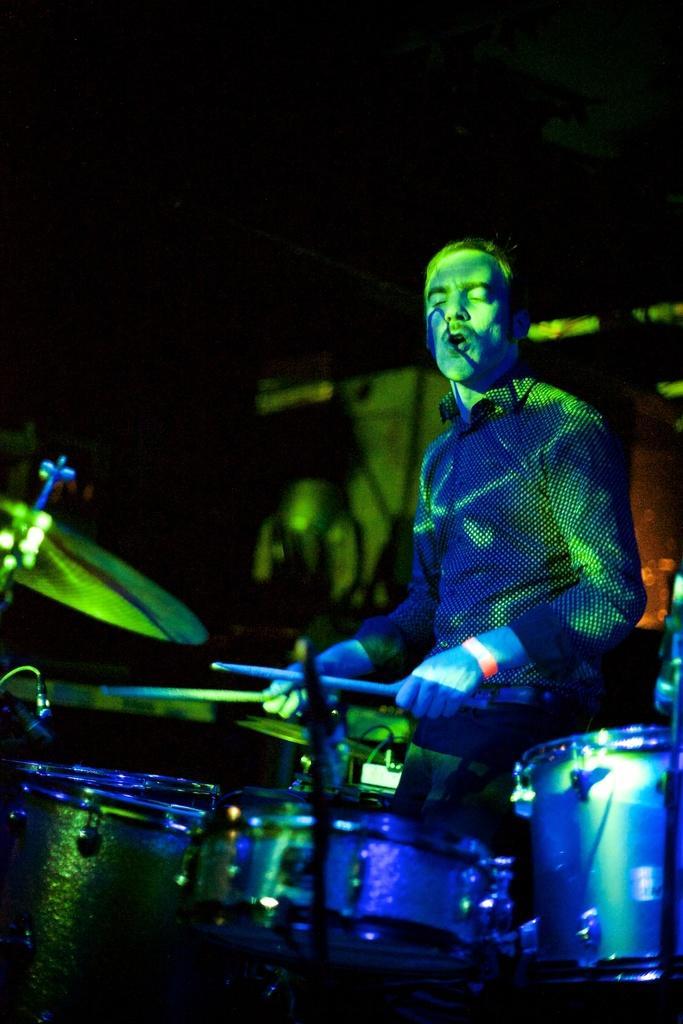Please provide a concise description of this image. In this picture we can observe a person sitting and playing drums which were in front of him. He is holding two sticks in his hand. We can observe green and blue color lights in this picture. The background is completely dark. 